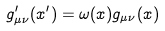Convert formula to latex. <formula><loc_0><loc_0><loc_500><loc_500>g ^ { \prime } _ { \mu \nu } ( x ^ { \prime } ) = \omega ( x ) g _ { \mu \nu } ( x ) \,</formula> 